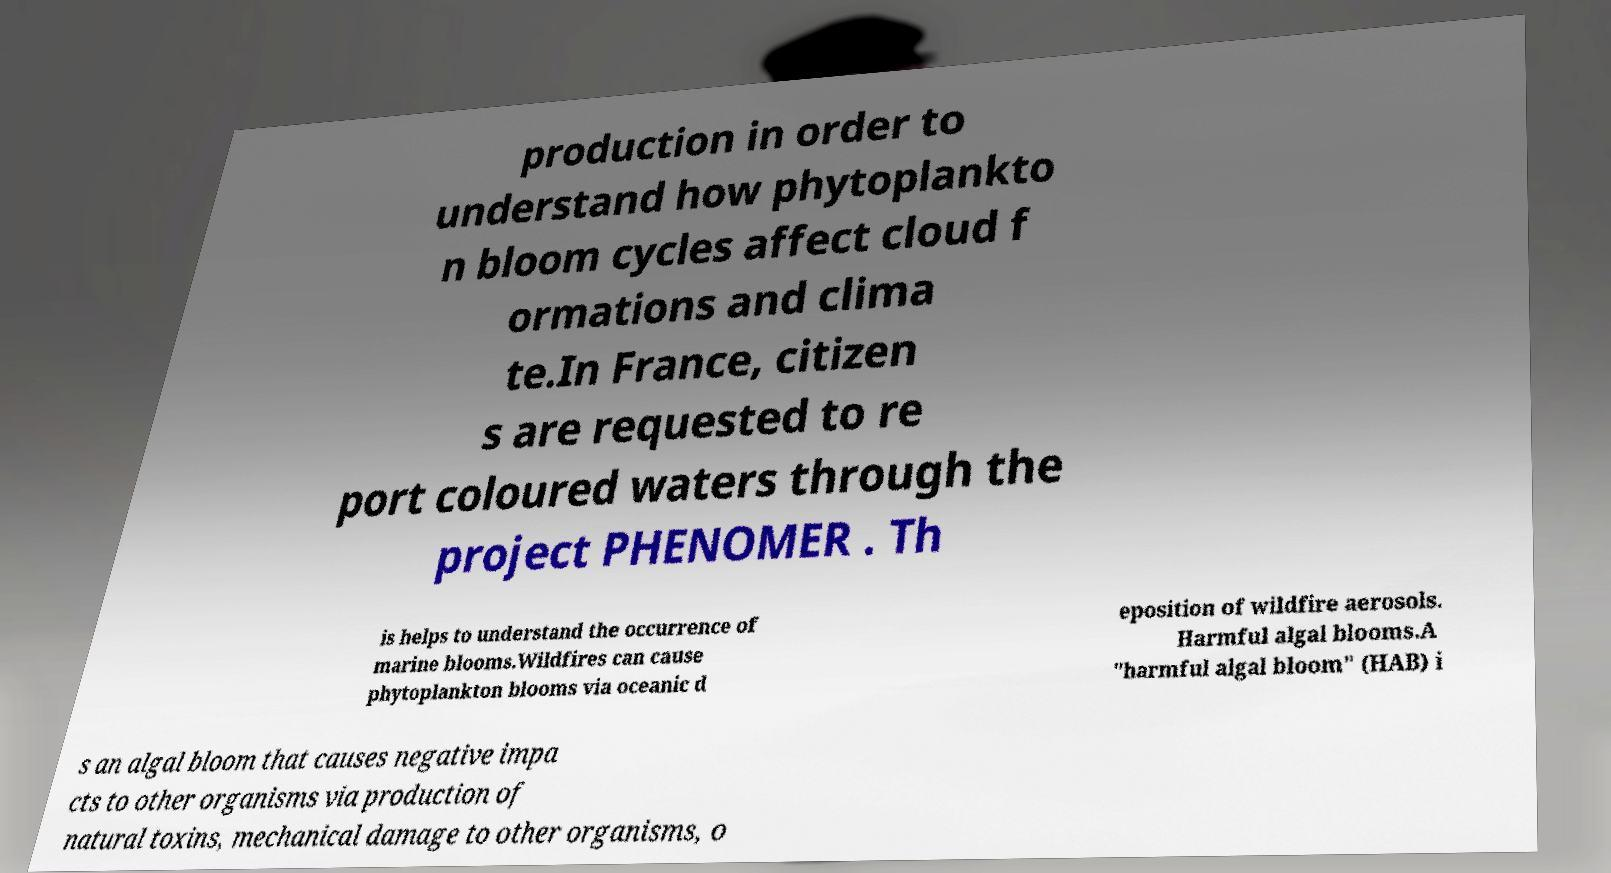For documentation purposes, I need the text within this image transcribed. Could you provide that? production in order to understand how phytoplankto n bloom cycles affect cloud f ormations and clima te.In France, citizen s are requested to re port coloured waters through the project PHENOMER . Th is helps to understand the occurrence of marine blooms.Wildfires can cause phytoplankton blooms via oceanic d eposition of wildfire aerosols. Harmful algal blooms.A "harmful algal bloom" (HAB) i s an algal bloom that causes negative impa cts to other organisms via production of natural toxins, mechanical damage to other organisms, o 